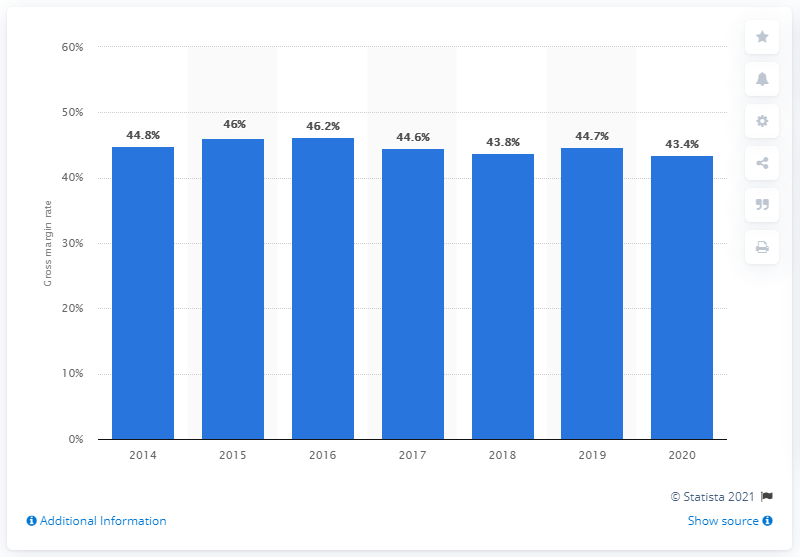Specify some key components in this picture. In 2020, Nike's global gross profit margin was 43.4%. 